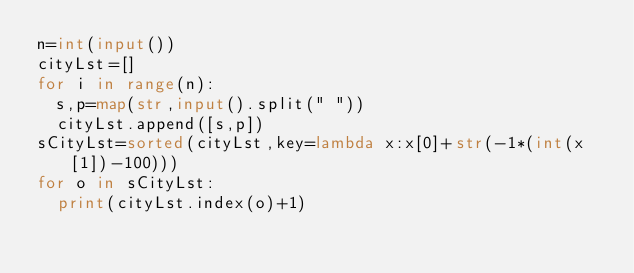Convert code to text. <code><loc_0><loc_0><loc_500><loc_500><_Python_>n=int(input())
cityLst=[]
for i in range(n):
	s,p=map(str,input().split(" "))
	cityLst.append([s,p])
sCityLst=sorted(cityLst,key=lambda x:x[0]+str(-1*(int(x[1])-100)))
for o in sCityLst:
	print(cityLst.index(o)+1)</code> 